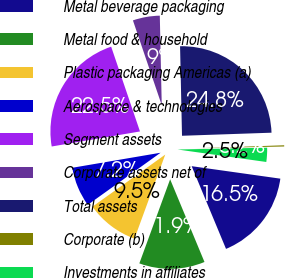Convert chart. <chart><loc_0><loc_0><loc_500><loc_500><pie_chart><fcel>Metal beverage packaging<fcel>Metal food & household<fcel>Plastic packaging Americas (a)<fcel>Aerospace & technologies<fcel>Segment assets<fcel>Corporate assets net of<fcel>Total assets<fcel>Corporate (b)<fcel>Investments in affiliates<nl><fcel>16.51%<fcel>11.85%<fcel>9.53%<fcel>7.2%<fcel>22.47%<fcel>4.87%<fcel>24.8%<fcel>0.22%<fcel>2.55%<nl></chart> 